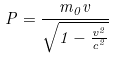<formula> <loc_0><loc_0><loc_500><loc_500>P = \frac { m _ { 0 } v } { \sqrt { 1 - \frac { v ^ { 2 } } { c ^ { 2 } } } }</formula> 